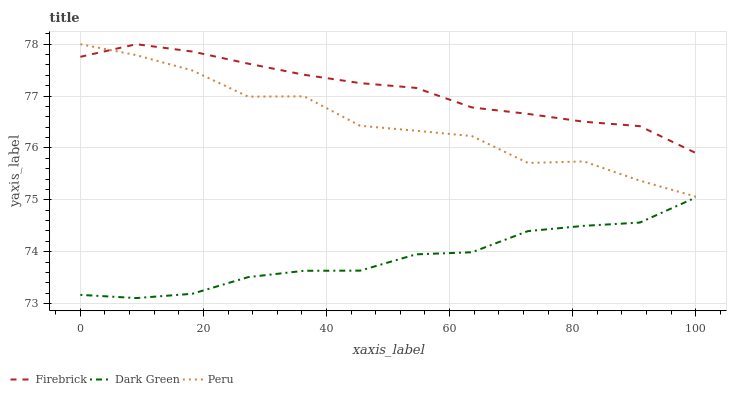Does Dark Green have the minimum area under the curve?
Answer yes or no. Yes. Does Firebrick have the maximum area under the curve?
Answer yes or no. Yes. Does Peru have the minimum area under the curve?
Answer yes or no. No. Does Peru have the maximum area under the curve?
Answer yes or no. No. Is Firebrick the smoothest?
Answer yes or no. Yes. Is Peru the roughest?
Answer yes or no. Yes. Is Dark Green the smoothest?
Answer yes or no. No. Is Dark Green the roughest?
Answer yes or no. No. Does Dark Green have the lowest value?
Answer yes or no. Yes. Does Peru have the lowest value?
Answer yes or no. No. Does Peru have the highest value?
Answer yes or no. Yes. Does Dark Green have the highest value?
Answer yes or no. No. Is Dark Green less than Peru?
Answer yes or no. Yes. Is Peru greater than Dark Green?
Answer yes or no. Yes. Does Firebrick intersect Peru?
Answer yes or no. Yes. Is Firebrick less than Peru?
Answer yes or no. No. Is Firebrick greater than Peru?
Answer yes or no. No. Does Dark Green intersect Peru?
Answer yes or no. No. 